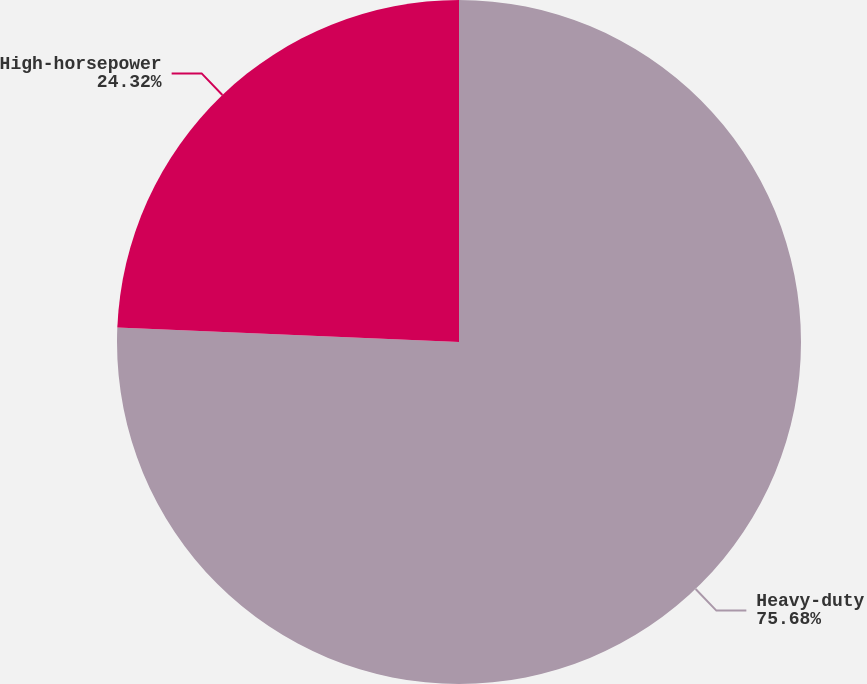Convert chart to OTSL. <chart><loc_0><loc_0><loc_500><loc_500><pie_chart><fcel>Heavy-duty<fcel>High-horsepower<nl><fcel>75.68%<fcel>24.32%<nl></chart> 